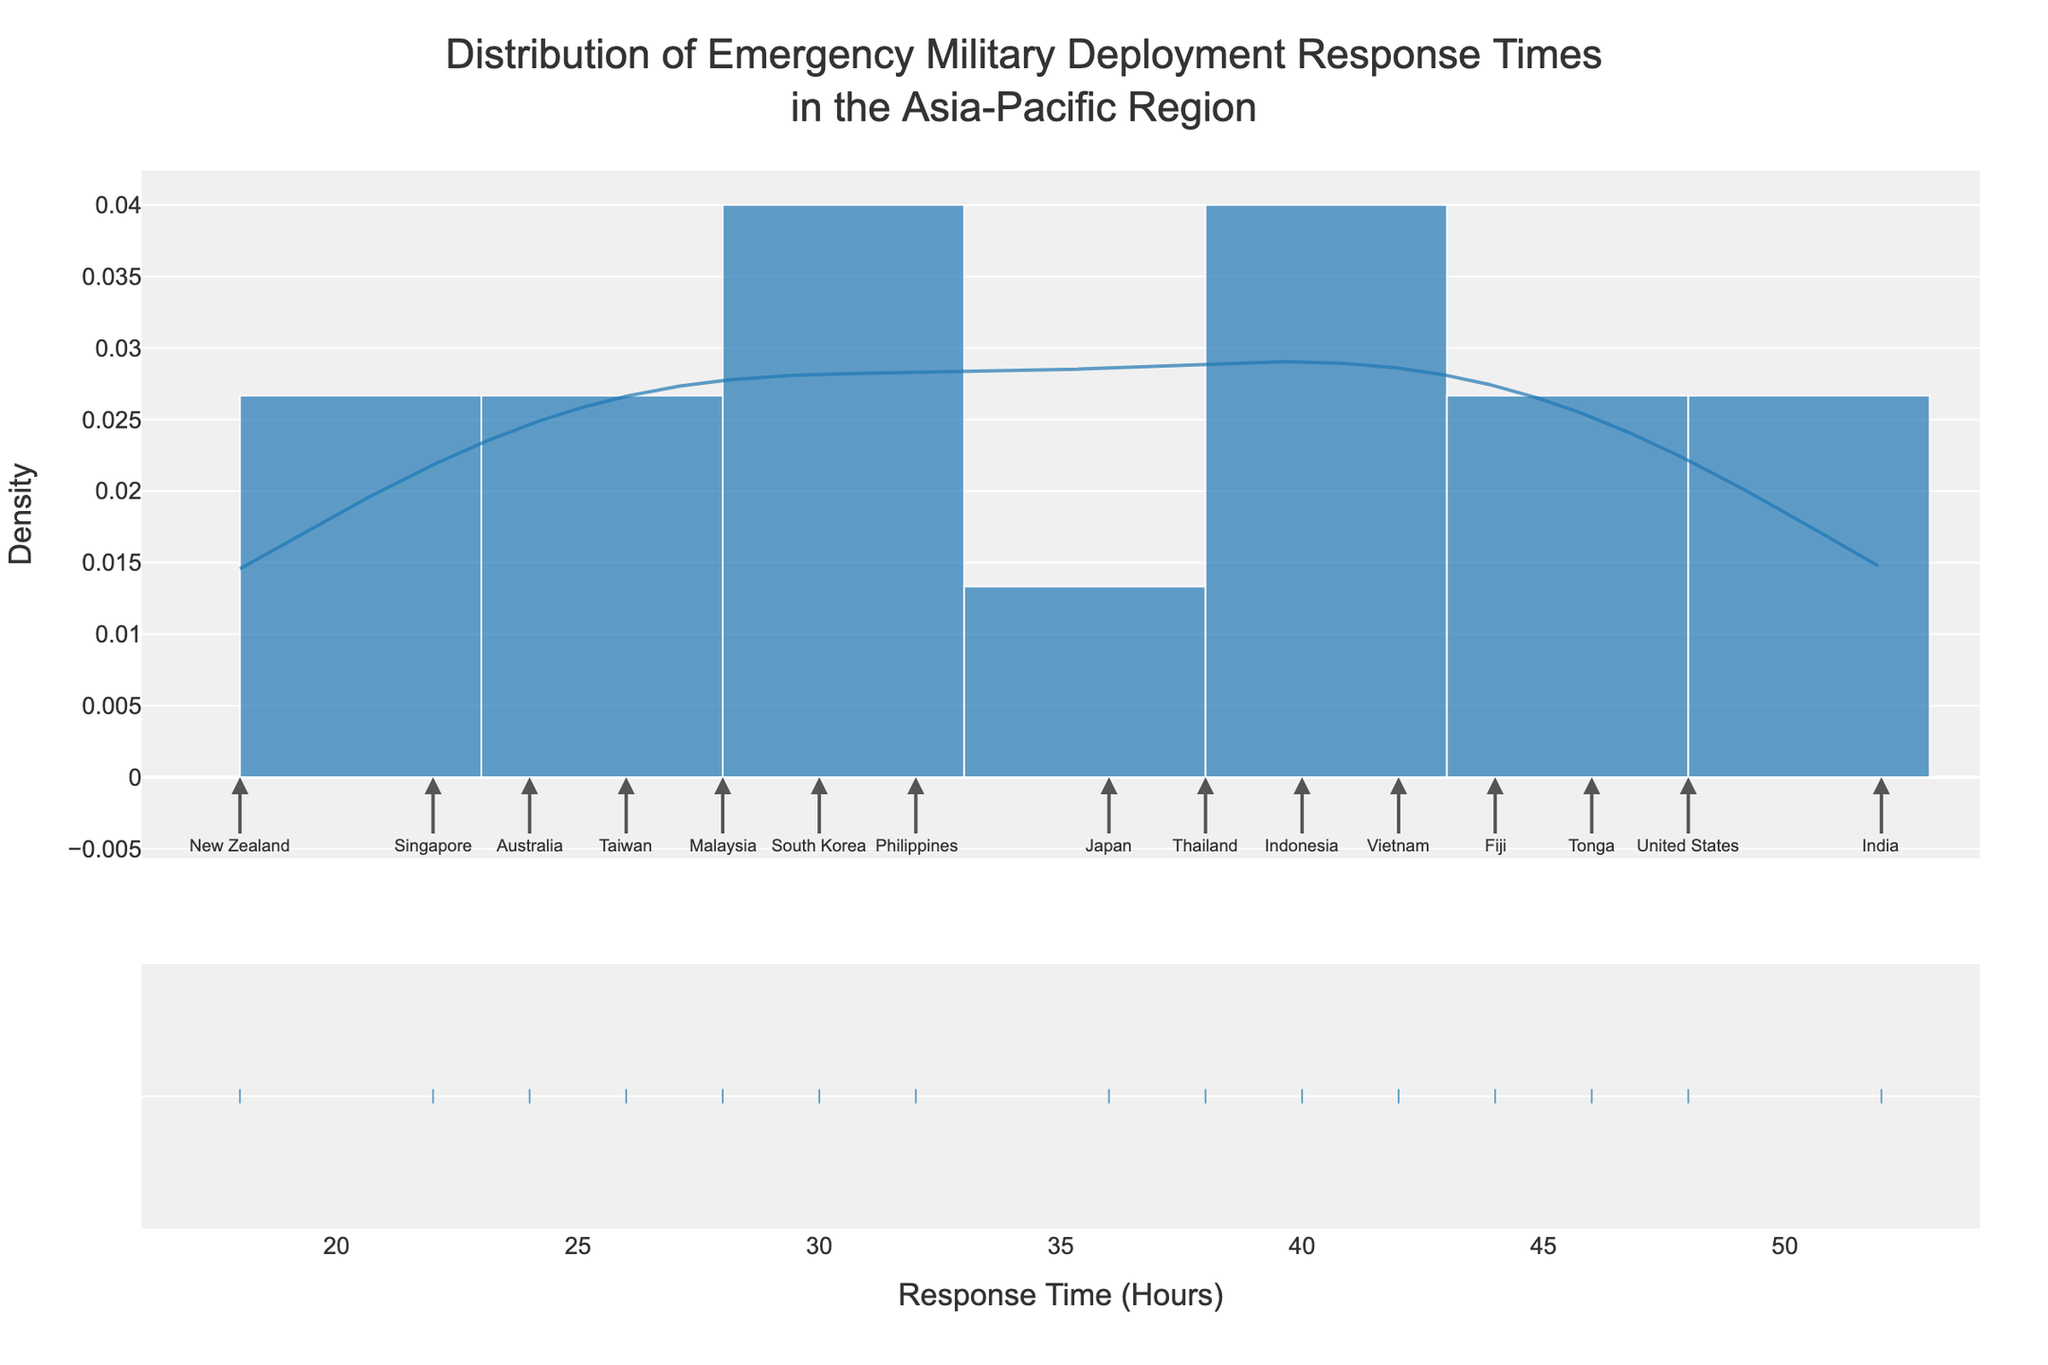What is the title of the plot? The title is usually written at the top and provides a summary of the plot's content. In this case, the title reads "Distribution of Emergency Military Deployment Response Times in the Asia-Pacific Region".
Answer: Distribution of Emergency Military Deployment Response Times in the Asia-Pacific Region What does the x-axis represent? The x-axis typically represents the variable being measured. In this figure, the x-axis label is "Response Time (Hours)", indicating it measures the response times in hours.
Answer: Response Time (Hours) What is the y-axis label? The y-axis label describes what is being measured along the y-axis. The label here is "Density", indicating it measures the probability density of the response times.
Answer: Density Which country has the shortest emergency response time? Annotations on the histogram show the response times for various countries. By locating the shortest bar, we see "New Zealand" at 18 hours.
Answer: New Zealand Which country has the longest emergency response time? Similar to finding the shortest response time, the longest response time annotation shows "India" at 52 hours.
Answer: India How many countries have a response time shorter than 30 hours? Based on the annotations, count the countries with response times less than 30. These countries are Australia, New Zealand, Singapore, and Taiwan.
Answer: 4 What is the range of the response times displayed in the plot? The range is found by subtracting the smallest value from the largest. Observing the plot, the shortest time is 18 hours (New Zealand) and the longest is 52 hours (India). So, 52 - 18 = 34 hours.
Answer: 34 hours Which country's response time is closest to the average response time? First, calculate the average of all response times by summing them and dividing by the number of countries. The average is (24 + 18 + 36 + 30 + 48 + 22 + 28 + 40 + 32 + 38 + 42 + 52 + 26 + 44 + 46) / 15 = 34.6 hours. Next, identify the country whose response time (32 hours for the Philippines) is closest to this average.
Answer: Philippines How does the density peak relate to the majority of the response times? The density peak represents the most frequent range of response times. Observing the KDE curve, the peak is around 32 hours, suggesting that a significant number of countries have response times close to this value.
Answer: Peak is around 32 hours Are there any countries with response times significantly different from the rest? By examining the distribution, identify any outliers that deviate significantly. India's 52 hours and New Zealand's 18 hours are outliers compared to other response times clustered around 30-40 hours.
Answer: India and New Zealand 